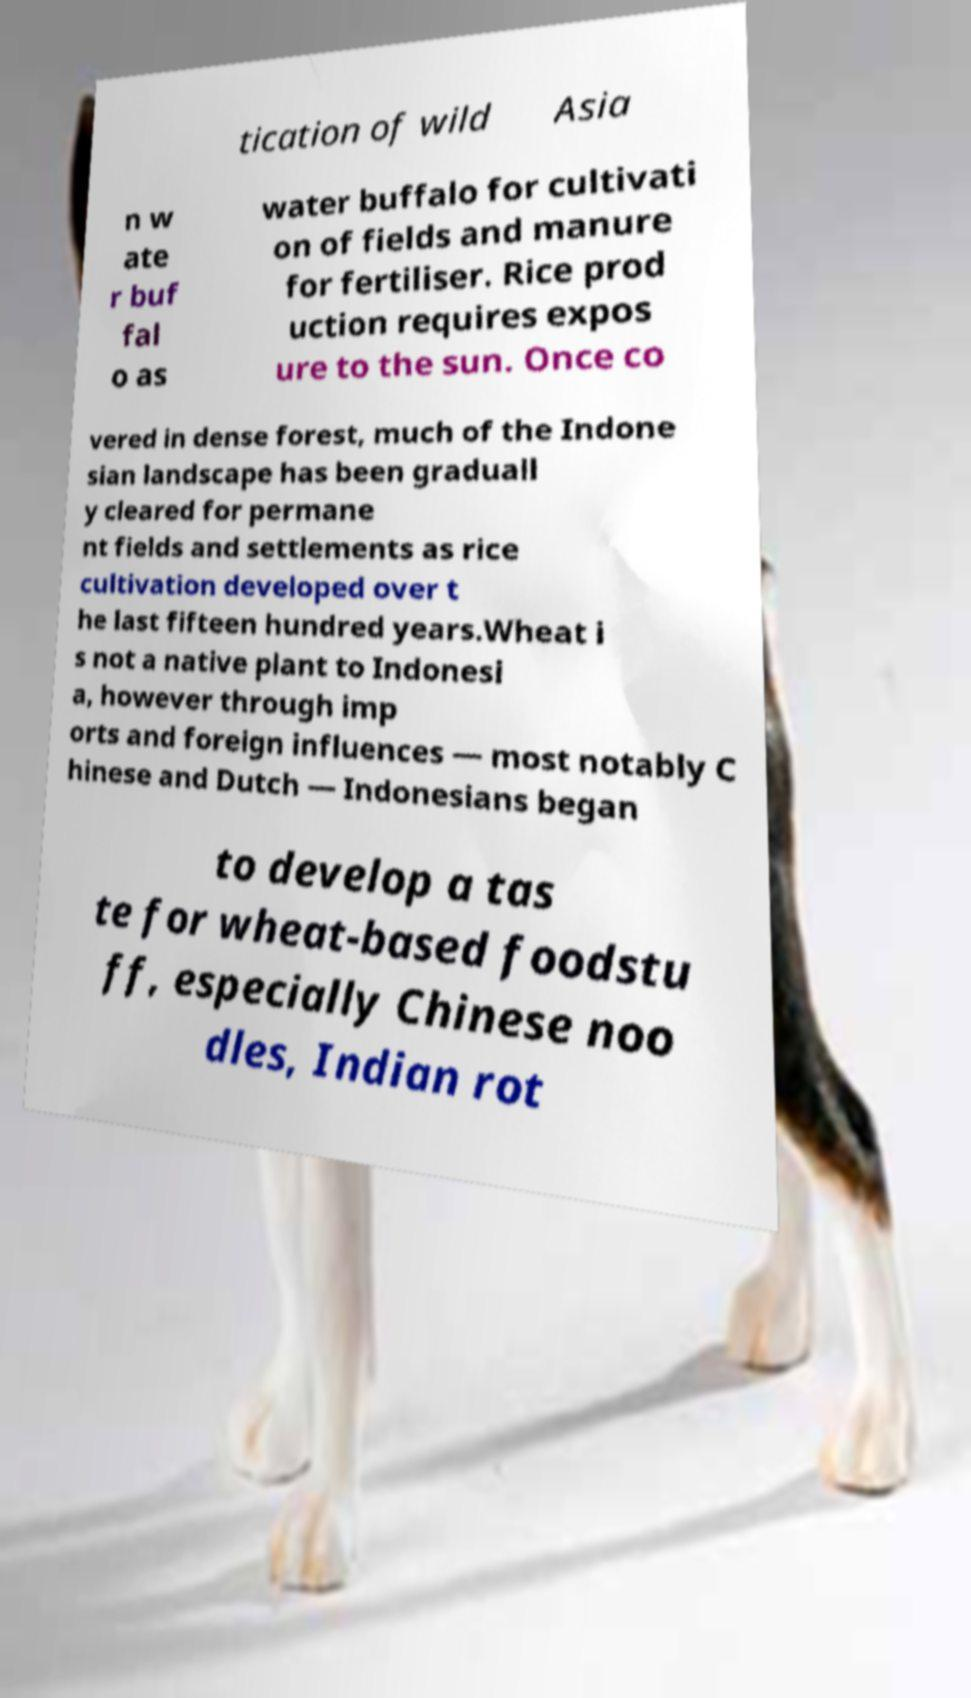Can you accurately transcribe the text from the provided image for me? tication of wild Asia n w ate r buf fal o as water buffalo for cultivati on of fields and manure for fertiliser. Rice prod uction requires expos ure to the sun. Once co vered in dense forest, much of the Indone sian landscape has been graduall y cleared for permane nt fields and settlements as rice cultivation developed over t he last fifteen hundred years.Wheat i s not a native plant to Indonesi a, however through imp orts and foreign influences — most notably C hinese and Dutch — Indonesians began to develop a tas te for wheat-based foodstu ff, especially Chinese noo dles, Indian rot 